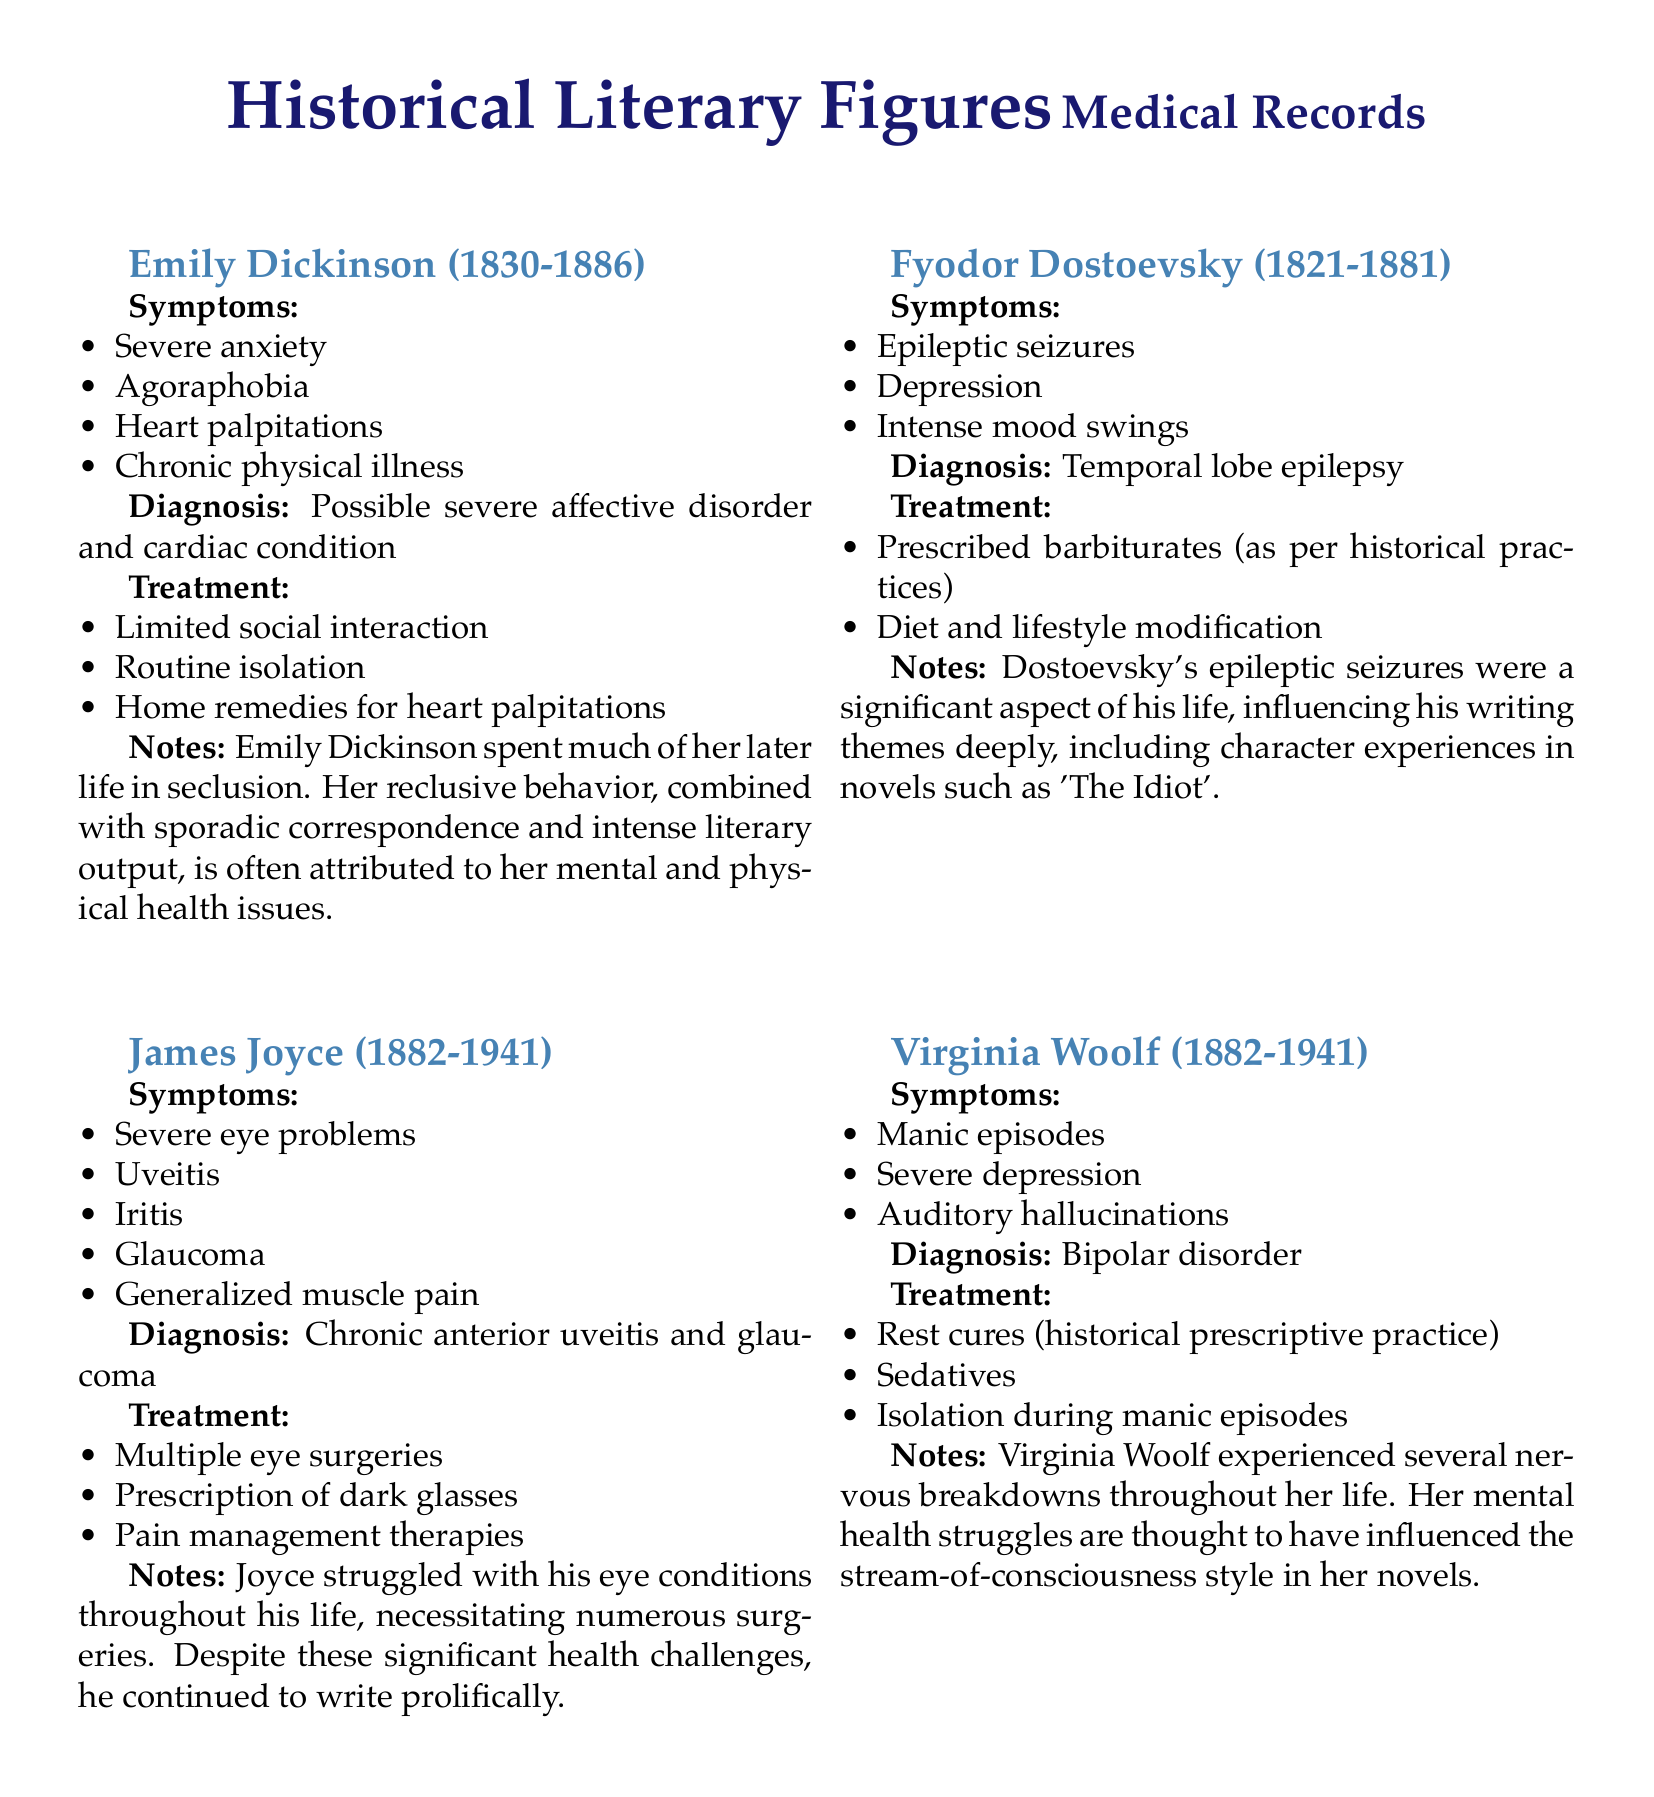what were the main symptoms of Emily Dickinson? The symptoms listed for Emily Dickinson include severe anxiety, agoraphobia, heart palpitations, and chronic physical illness.
Answer: severe anxiety, agoraphobia, heart palpitations, chronic physical illness what was Fyodor Dostoevsky's diagnosis? Fyodor Dostoevsky was diagnosed with temporal lobe epilepsy according to the medical record.
Answer: temporal lobe epilepsy how many literary figures' medical records are mentioned in the document? The document includes the medical records of four literary figures: Emily Dickinson, Fyodor Dostoevsky, James Joyce, and Virginia Woolf.
Answer: four what treatment did James Joyce undergo? James Joyce underwent multiple eye surgeries as part of his treatment for his eye conditions.
Answer: multiple eye surgeries which disorder was Virginia Woolf diagnosed with? Virginia Woolf was diagnosed with bipolar disorder, as indicated in her medical record.
Answer: bipolar disorder what significant influence did Dostoevsky's health issues have on his writing? Dostoevsky's epileptic seizures significantly influenced the themes in his writing, particularly character experiences in his novels.
Answer: themes in his writing what type of treatment did Virginia Woolf receive for her condition? Virginia Woolf received rest cures, sedatives, and isolation during manic episodes as treatments for her condition.
Answer: rest cures, sedatives, isolation what does the document classify as Emily Dickinson's treatment methods? The treatment methods for Emily Dickinson included limited social interaction and routine isolation, reflecting her lifestyle choices based on her health issues.
Answer: limited social interaction, routine isolation 